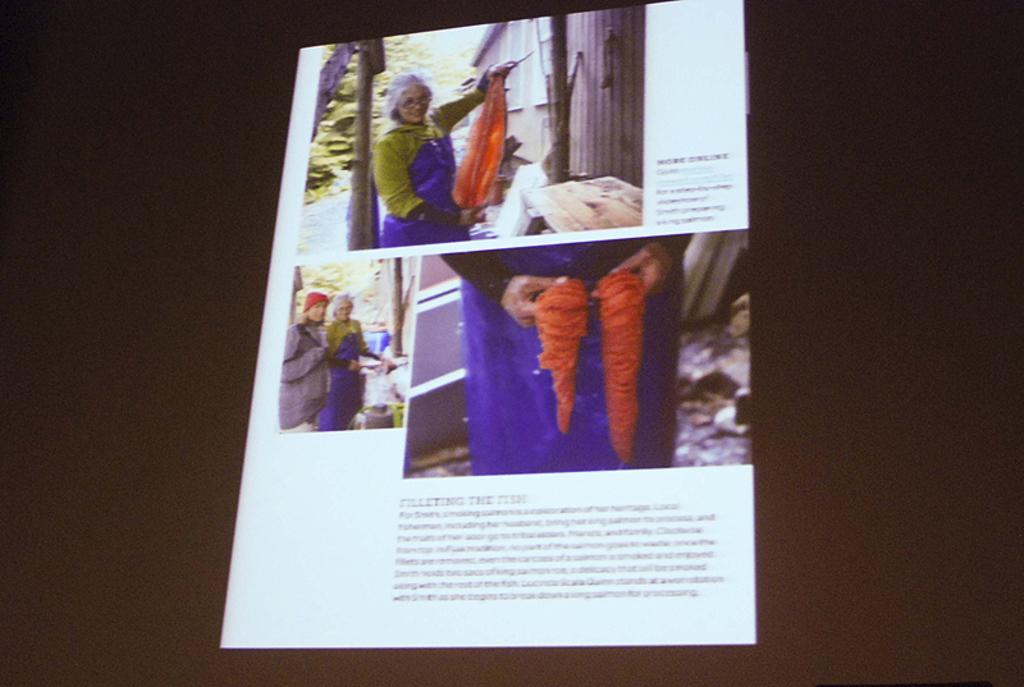What is the main object in the image? There is a screen in the image. What can be seen on the screen? Pictures and text are visible on the screen. What is the color of the background in the image? The background of the image appears to be black. Can you see any screws or wires attached to the oatmeal in the image? There is no oatmeal present in the image, and therefore no screws or wires attached to it. 